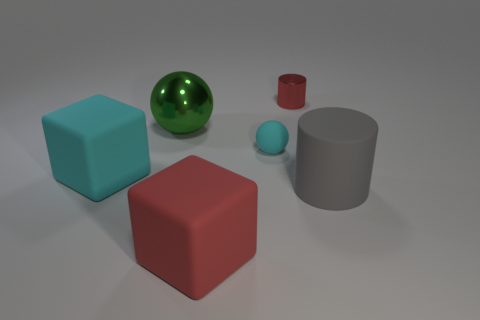Does the rubber cube behind the large red cube have the same color as the small thing on the left side of the tiny red cylinder?
Offer a terse response. Yes. What number of rubber things are green things or tiny blue balls?
Provide a short and direct response. 0. There is a object that is in front of the large matte thing to the right of the metallic cylinder; what shape is it?
Provide a succinct answer. Cube. Does the large thing that is on the right side of the small red metallic cylinder have the same material as the small object left of the red metal thing?
Offer a very short reply. Yes. There is a red thing that is in front of the small shiny object; what number of matte things are behind it?
Your answer should be compact. 3. There is a big object that is to the right of the cyan matte sphere; is it the same shape as the red object right of the large red rubber thing?
Make the answer very short. Yes. There is a object that is both to the right of the red matte object and to the left of the small red thing; what size is it?
Your answer should be very brief. Small. What color is the small metallic object that is the same shape as the gray matte thing?
Your answer should be very brief. Red. What color is the sphere right of the cube in front of the matte cylinder?
Keep it short and to the point. Cyan. The tiny cyan object has what shape?
Provide a short and direct response. Sphere. 